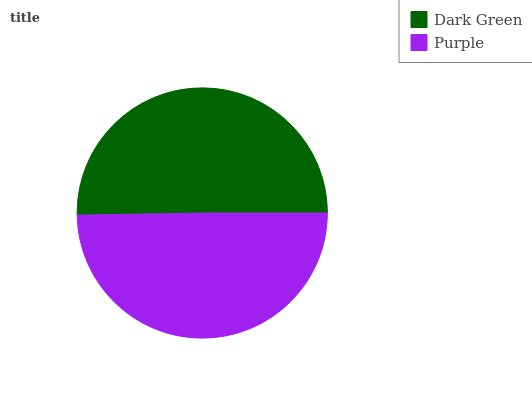Is Purple the minimum?
Answer yes or no. Yes. Is Dark Green the maximum?
Answer yes or no. Yes. Is Purple the maximum?
Answer yes or no. No. Is Dark Green greater than Purple?
Answer yes or no. Yes. Is Purple less than Dark Green?
Answer yes or no. Yes. Is Purple greater than Dark Green?
Answer yes or no. No. Is Dark Green less than Purple?
Answer yes or no. No. Is Dark Green the high median?
Answer yes or no. Yes. Is Purple the low median?
Answer yes or no. Yes. Is Purple the high median?
Answer yes or no. No. Is Dark Green the low median?
Answer yes or no. No. 